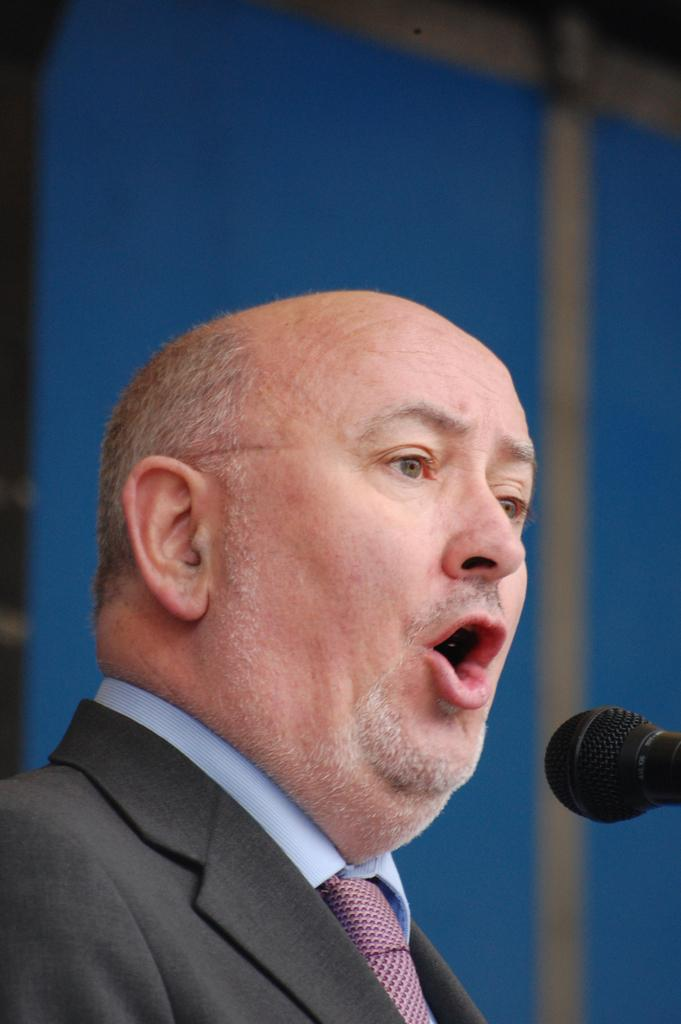Who is the person in the image? There is a man in the image. What is the man wearing? The man is wearing a suit. What is the man doing in the image? The man is talking in front of a microphone. Can you describe the background of the image? The background of the image has a blurred view. What color can be seen in the image? The color blue is present in the image. What hill can be seen in the background of the image? There is no hill visible in the background of the image; it has a blurred view. 